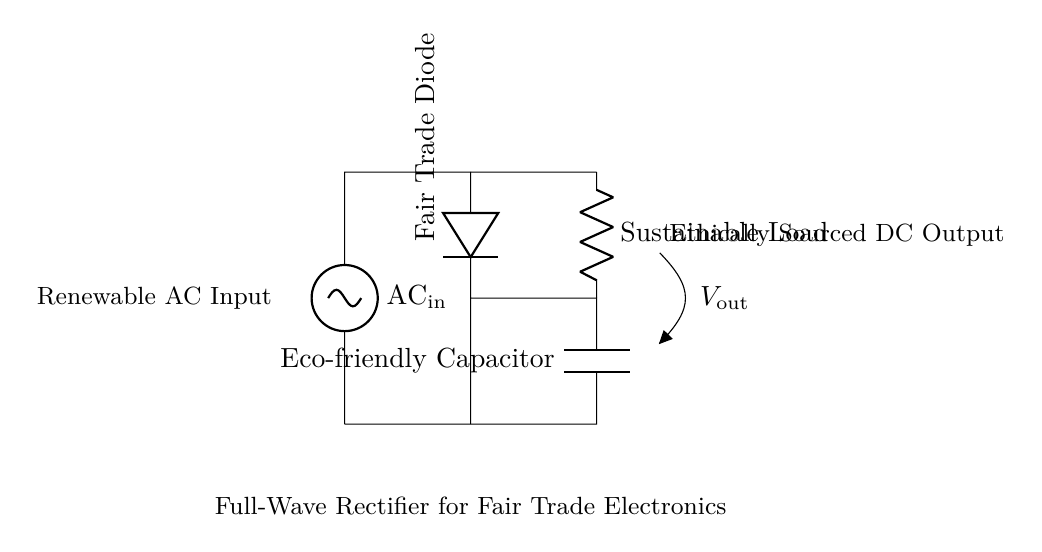What is the input type of this circuit? The circuit diagram shows that the input is designated as AC, specifically noted as "AC in." This indicates that the circuit starts with alternating current.
Answer: AC What type of diode is used in this rectifier? The circuit specifically labels the diode as a "Fair Trade Diode," which is a description indicating ethical sourcing. It is the only diode shown, which performs the rectification in the circuit.
Answer: Fair Trade Diode What component is used to smooth the output? The circuit includes an "Eco-friendly Capacitor" that is connected after the diode. Capacitors are commonly used to smooth out the output voltage from a rectifier circuit by filtering ripples.
Answer: Eco-friendly Capacitor What is the purpose of the load in this circuit? The "Sustainable Load" is placed in the circuit to utilize the converted DC power. It represents the device or machinery that will be powered, completing the electrical circuit.
Answer: Sustainable Load What voltage type does this circuit output? The diagram indicates that the output type is DC, as it's noted as "Ethically Sourced DC Output." The rectification process converts AC to DC for suitable applications.
Answer: DC What is the role of the capacitor in this design? The Eco-friendly Capacitor plays a critical role in the rectifier circuit by storing and smoothing the output voltage, preventing fluctuations and providing a more stable DC output. This is essential for powering sensitive electronic devices.
Answer: Smoothing the output How many diodes are used in this circuit? Upon examining the circuit, there is only one diode represented as the Fair Trade Diode. In full-wave rectifiers, typically two or four diodes are used, but this design employs a single diode for simplicity, which indicates it may be a half-wave rectifier.
Answer: One 